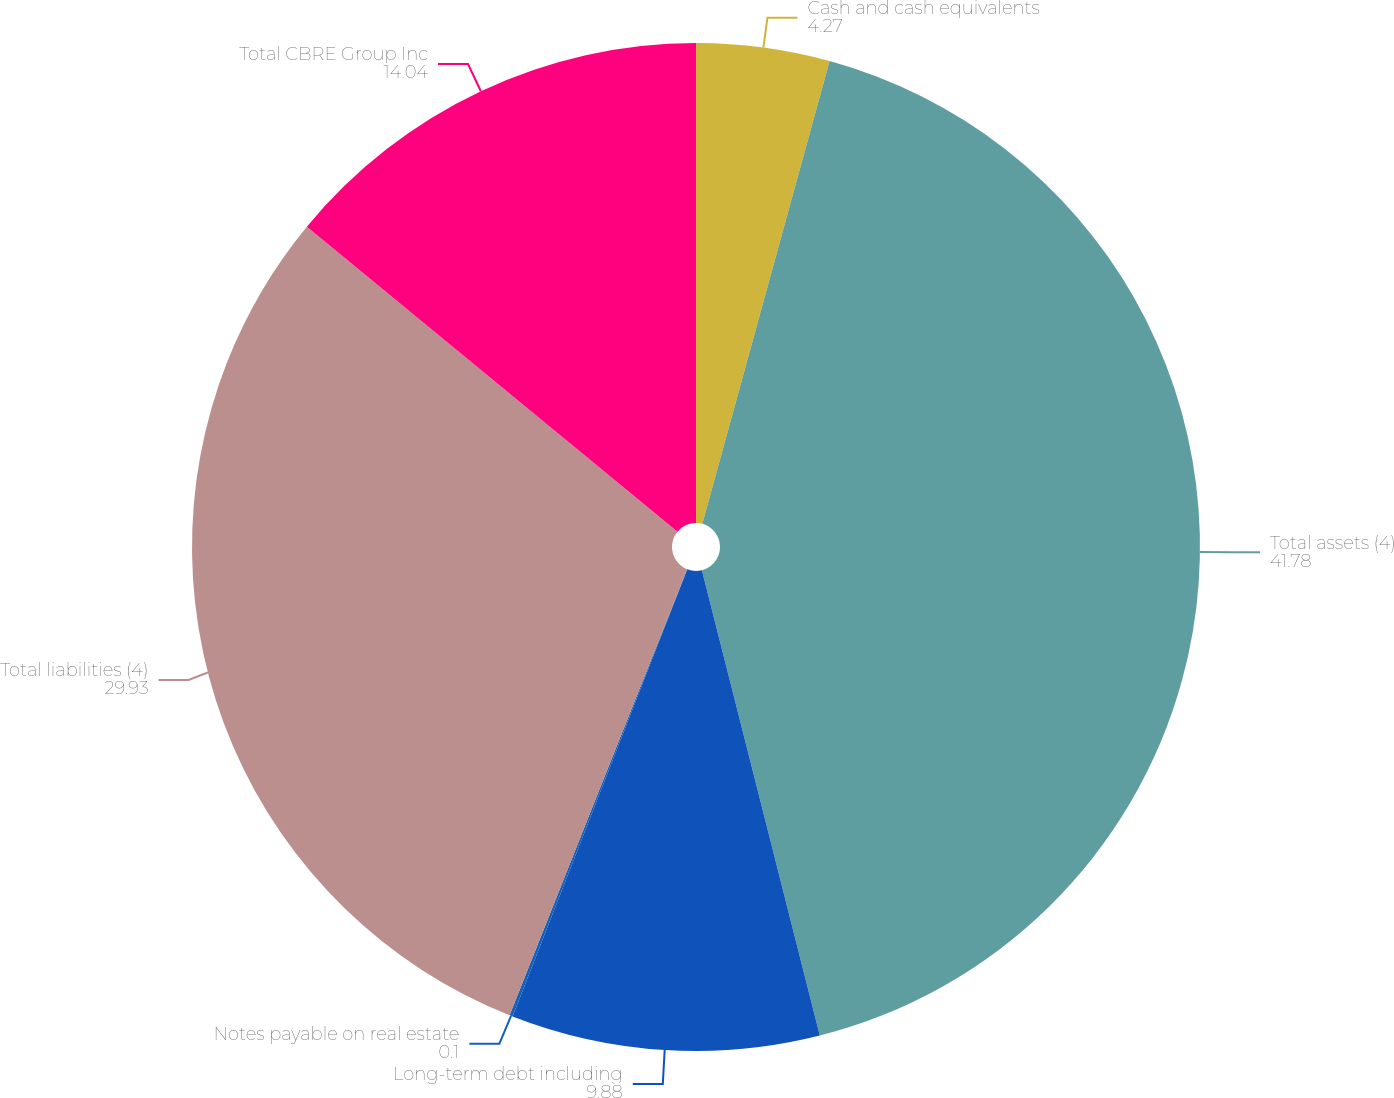Convert chart. <chart><loc_0><loc_0><loc_500><loc_500><pie_chart><fcel>Cash and cash equivalents<fcel>Total assets (4)<fcel>Long-term debt including<fcel>Notes payable on real estate<fcel>Total liabilities (4)<fcel>Total CBRE Group Inc<nl><fcel>4.27%<fcel>41.78%<fcel>9.88%<fcel>0.1%<fcel>29.93%<fcel>14.04%<nl></chart> 